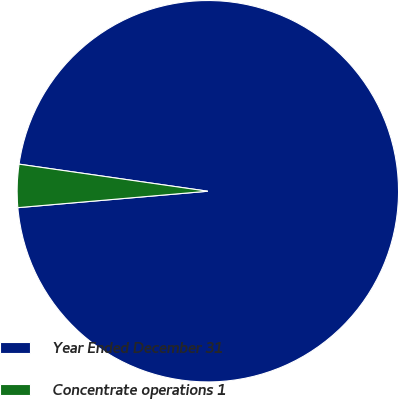Convert chart. <chart><loc_0><loc_0><loc_500><loc_500><pie_chart><fcel>Year Ended December 31<fcel>Concentrate operations 1<nl><fcel>96.36%<fcel>3.64%<nl></chart> 